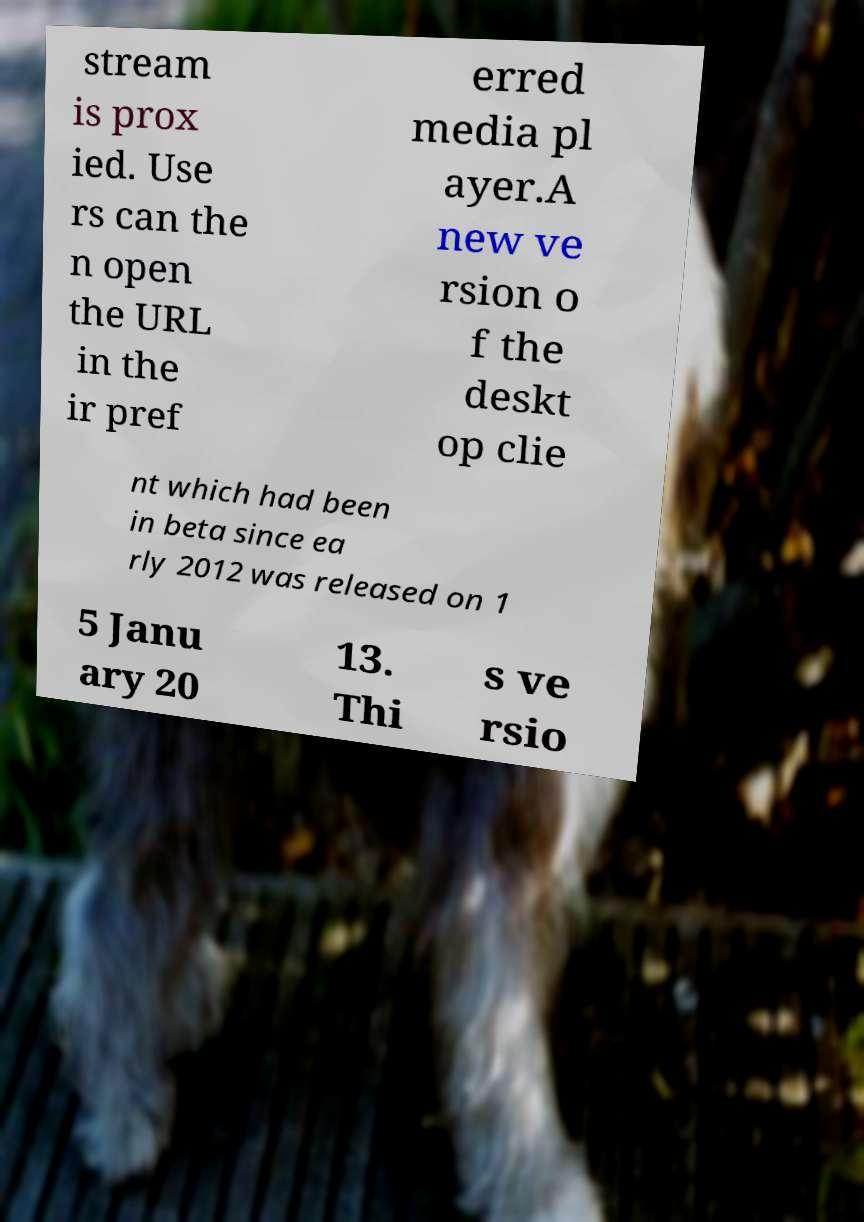Please read and relay the text visible in this image. What does it say? stream is prox ied. Use rs can the n open the URL in the ir pref erred media pl ayer.A new ve rsion o f the deskt op clie nt which had been in beta since ea rly 2012 was released on 1 5 Janu ary 20 13. Thi s ve rsio 